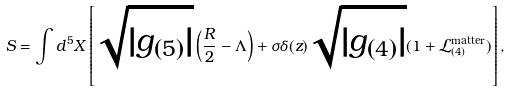Convert formula to latex. <formula><loc_0><loc_0><loc_500><loc_500>S = \int d ^ { 5 } X \left [ \sqrt { | g _ { ( 5 ) } | } \left ( \frac { R } { 2 } - \Lambda \right ) + \sigma \delta ( z ) \sqrt { | g _ { ( 4 ) } | } ( 1 + \mathcal { L } _ { ( 4 ) } ^ { \text {matter} } ) \right ] ,</formula> 